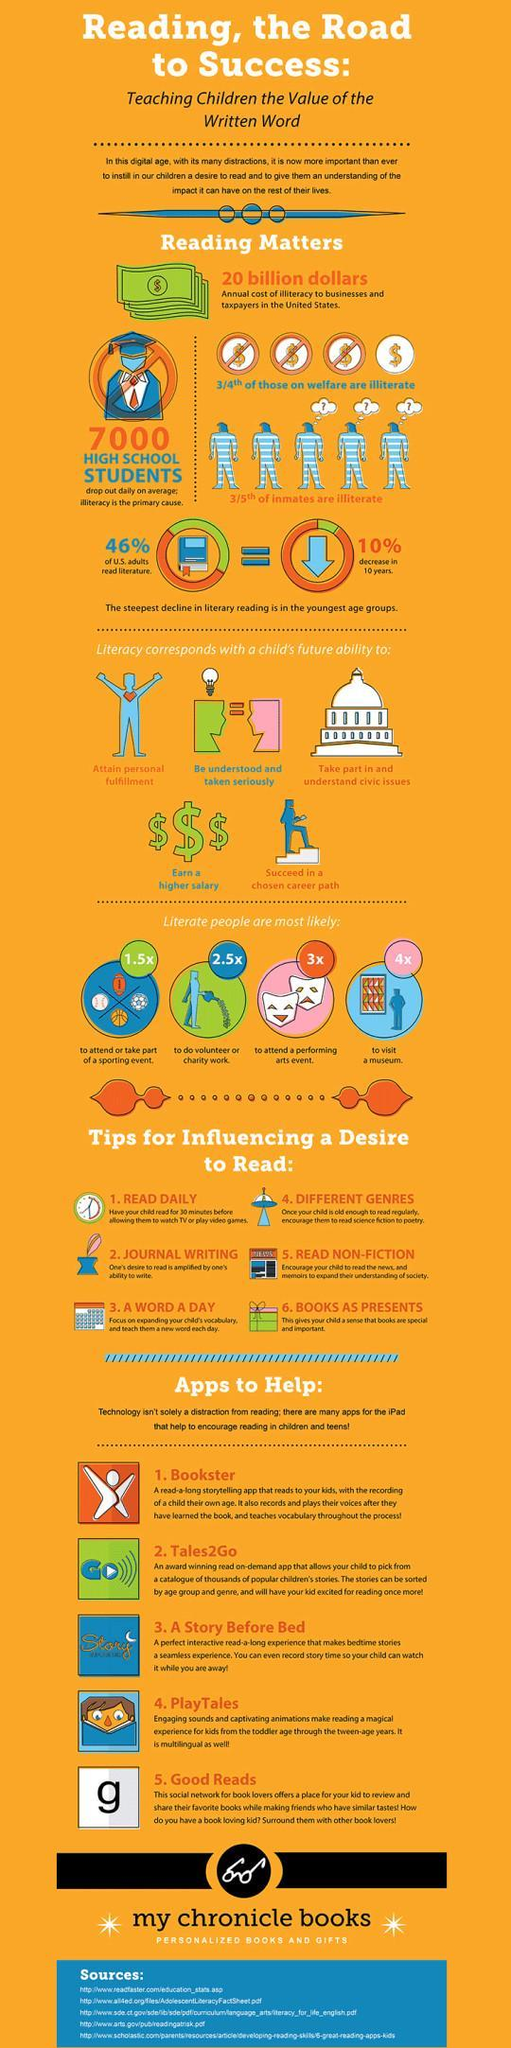What percentage of U.S adults didn't read literature?
Answer the question with a short phrase. 54% How many points are under the title "Literacy corresponds with a child's future ability to"? 5 